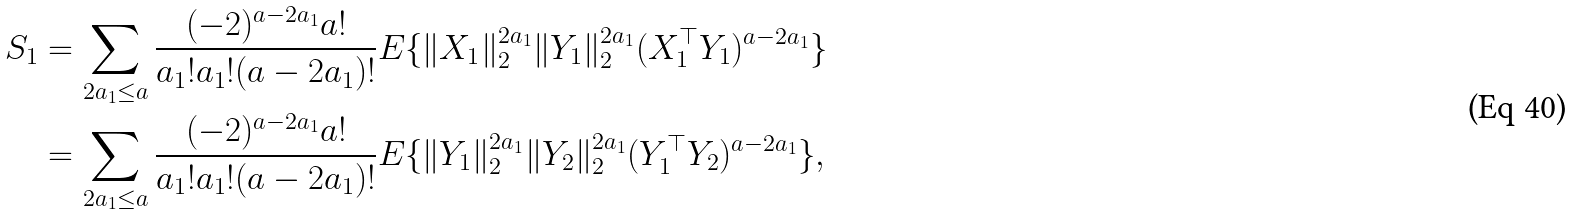Convert formula to latex. <formula><loc_0><loc_0><loc_500><loc_500>S _ { 1 } & = \sum _ { 2 a _ { 1 } \leq a } \frac { ( - 2 ) ^ { a - 2 a _ { 1 } } a ! } { a _ { 1 } ! a _ { 1 } ! ( a - 2 a _ { 1 } ) ! } E \{ \| X _ { 1 } \| _ { 2 } ^ { 2 a _ { 1 } } \| Y _ { 1 } \| _ { 2 } ^ { 2 a _ { 1 } } ( X _ { 1 } ^ { \top } Y _ { 1 } ) ^ { a - 2 a _ { 1 } } \} \\ & = \sum _ { 2 a _ { 1 } \leq a } \frac { ( - 2 ) ^ { a - 2 a _ { 1 } } a ! } { a _ { 1 } ! a _ { 1 } ! ( a - 2 a _ { 1 } ) ! } E \{ \| Y _ { 1 } \| _ { 2 } ^ { 2 a _ { 1 } } \| Y _ { 2 } \| _ { 2 } ^ { 2 a _ { 1 } } ( Y _ { 1 } ^ { \top } Y _ { 2 } ) ^ { a - 2 a _ { 1 } } \} ,</formula> 